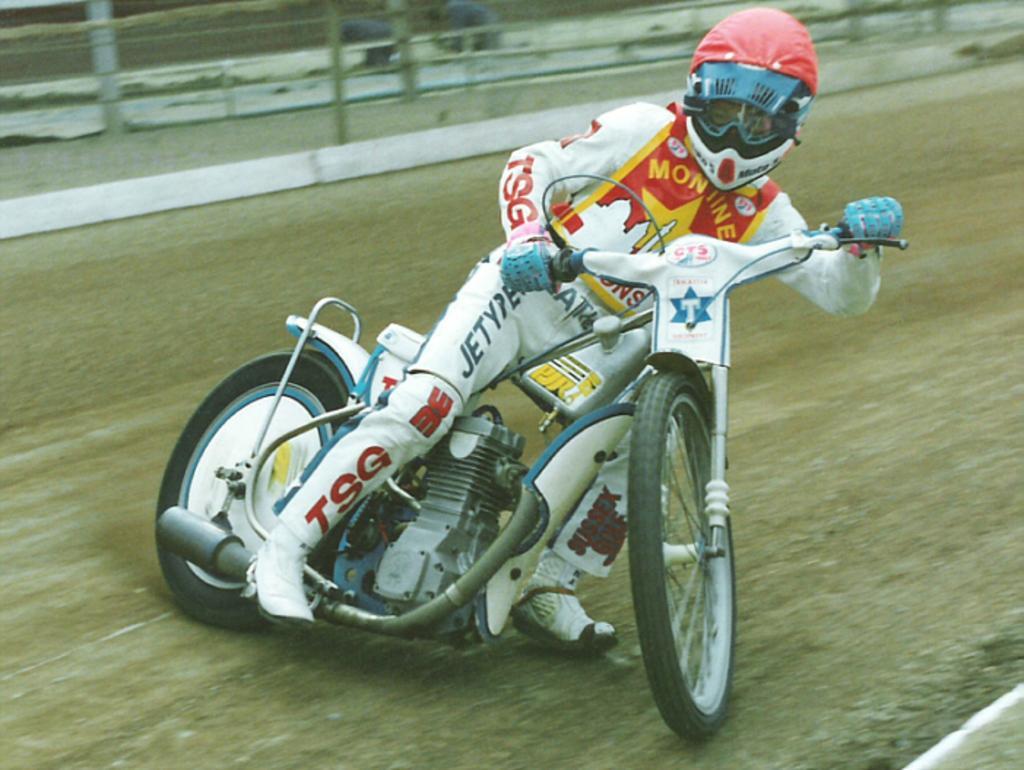Can you describe this image briefly? In this image we can see a man is riding white bike. He is wearing white dress and red helmet. Background of the image fencing is there. 